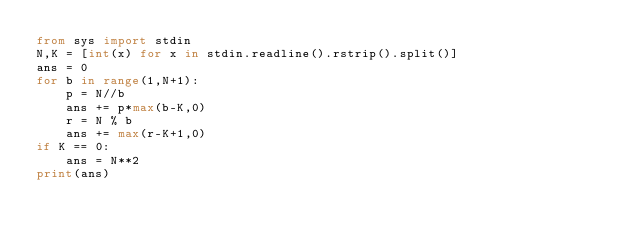Convert code to text. <code><loc_0><loc_0><loc_500><loc_500><_Python_>from sys import stdin
N,K = [int(x) for x in stdin.readline().rstrip().split()]
ans = 0
for b in range(1,N+1):
    p = N//b
    ans += p*max(b-K,0)
    r = N % b
    ans += max(r-K+1,0)
if K == 0:
    ans = N**2
print(ans)</code> 